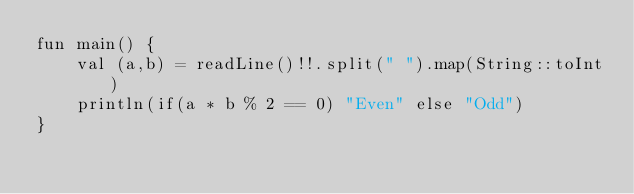<code> <loc_0><loc_0><loc_500><loc_500><_Kotlin_>fun main() {
    val (a,b) = readLine()!!.split(" ").map(String::toInt)
    println(if(a * b % 2 == 0) "Even" else "Odd")
}
</code> 